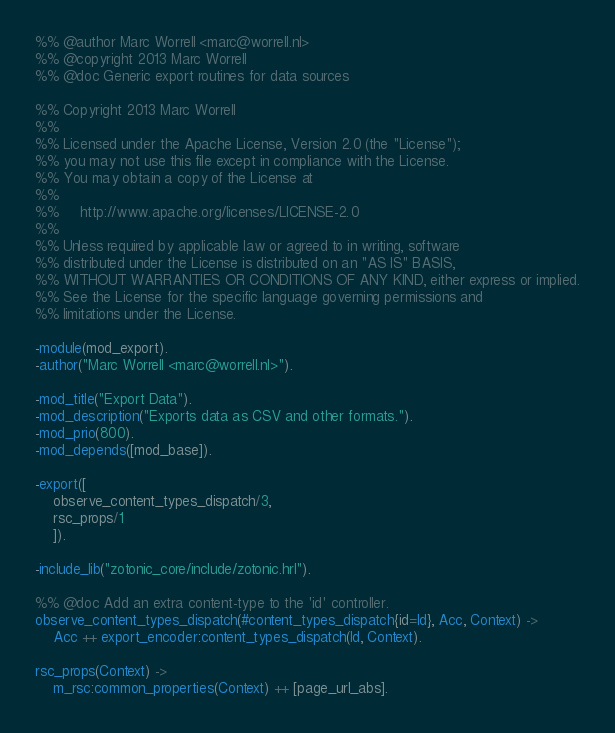Convert code to text. <code><loc_0><loc_0><loc_500><loc_500><_Erlang_>%% @author Marc Worrell <marc@worrell.nl>
%% @copyright 2013 Marc Worrell
%% @doc Generic export routines for data sources

%% Copyright 2013 Marc Worrell
%%
%% Licensed under the Apache License, Version 2.0 (the "License");
%% you may not use this file except in compliance with the License.
%% You may obtain a copy of the License at
%%
%%     http://www.apache.org/licenses/LICENSE-2.0
%%
%% Unless required by applicable law or agreed to in writing, software
%% distributed under the License is distributed on an "AS IS" BASIS,
%% WITHOUT WARRANTIES OR CONDITIONS OF ANY KIND, either express or implied.
%% See the License for the specific language governing permissions and
%% limitations under the License.

-module(mod_export).
-author("Marc Worrell <marc@worrell.nl>").

-mod_title("Export Data").
-mod_description("Exports data as CSV and other formats.").
-mod_prio(800).
-mod_depends([mod_base]).

-export([
    observe_content_types_dispatch/3,
    rsc_props/1
    ]).

-include_lib("zotonic_core/include/zotonic.hrl").

%% @doc Add an extra content-type to the 'id' controller.
observe_content_types_dispatch(#content_types_dispatch{id=Id}, Acc, Context) ->
    Acc ++ export_encoder:content_types_dispatch(Id, Context).

rsc_props(Context) ->
    m_rsc:common_properties(Context) ++ [page_url_abs].
</code> 